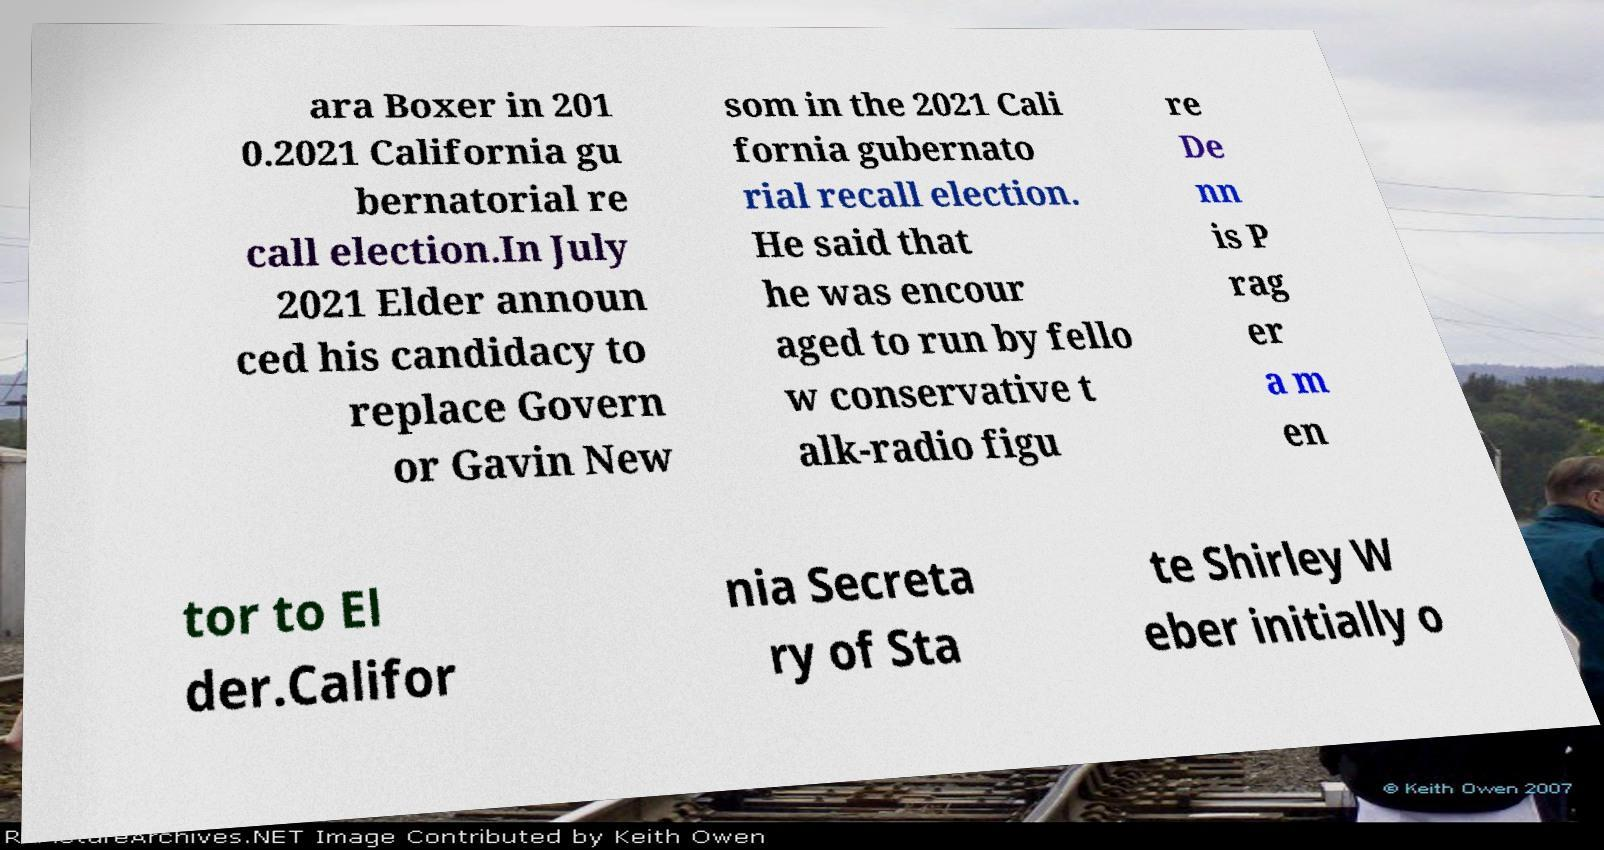I need the written content from this picture converted into text. Can you do that? ara Boxer in 201 0.2021 California gu bernatorial re call election.In July 2021 Elder announ ced his candidacy to replace Govern or Gavin New som in the 2021 Cali fornia gubernato rial recall election. He said that he was encour aged to run by fello w conservative t alk-radio figu re De nn is P rag er a m en tor to El der.Califor nia Secreta ry of Sta te Shirley W eber initially o 